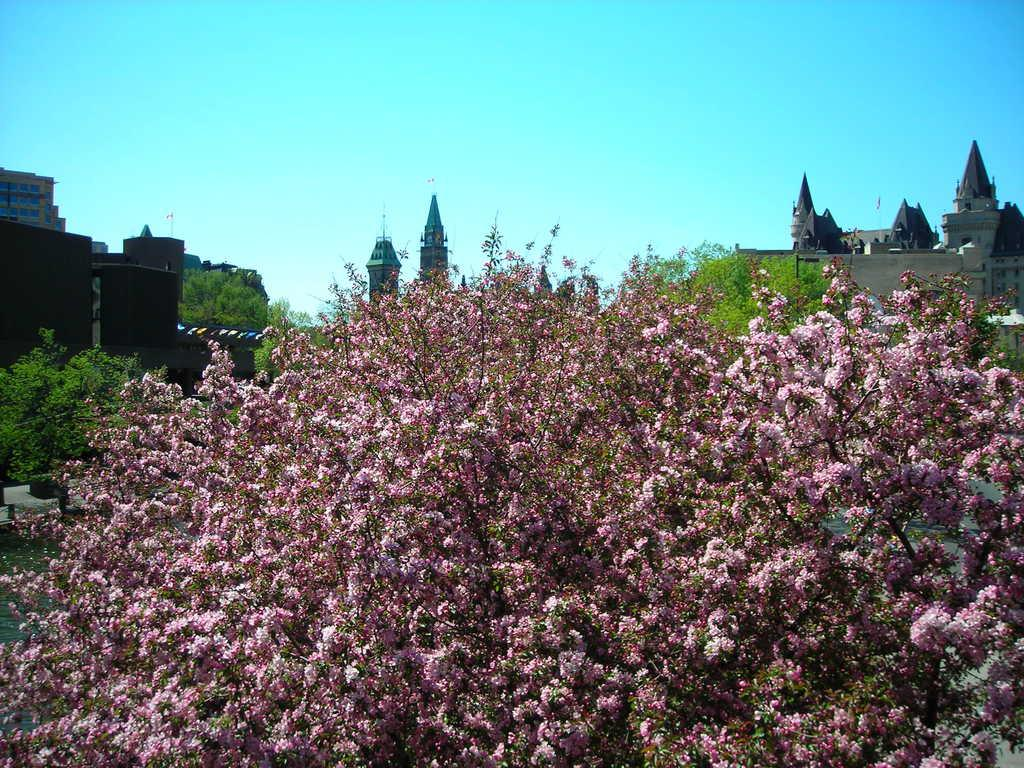What is located in the middle of the image? There are trees in the middle of the image. What can be seen behind the trees in the image? There are buildings behind the trees. What is visible at the top of the image? The sky is visible at the top of the image. What is the price of the tomatoes in the image? There are no tomatoes present in the image, so it is not possible to determine their price. Is there any oil visible in the image? There is no oil present in the image. 